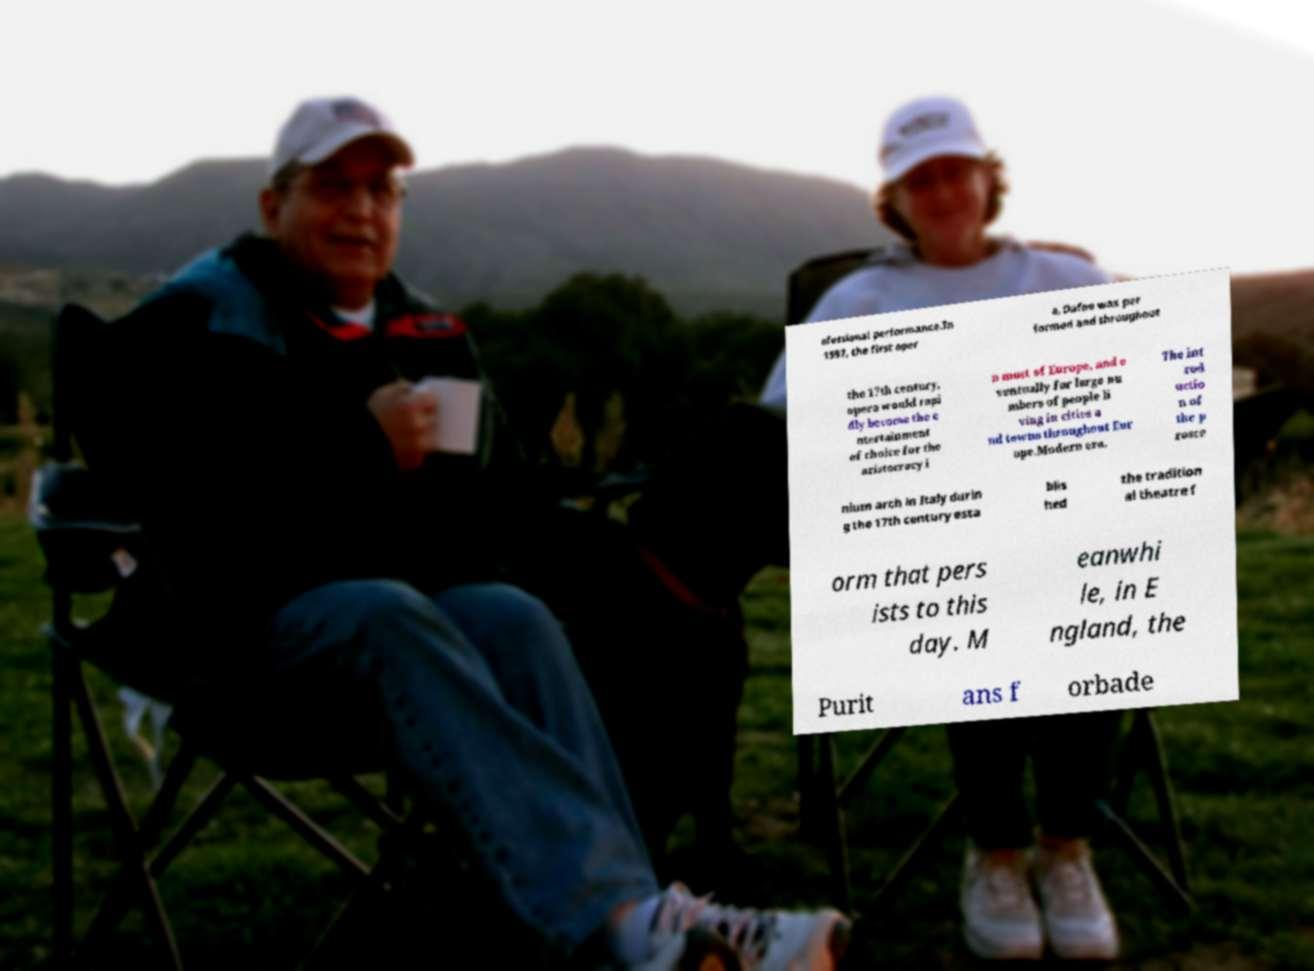Please identify and transcribe the text found in this image. ofessional performance.In 1597, the first oper a, Dafne was per formed and throughout the 17th century, opera would rapi dly become the e ntertainment of choice for the aristocracy i n most of Europe, and e ventually for large nu mbers of people li ving in cities a nd towns throughout Eur ope.Modern era. The int rod uctio n of the p rosce nium arch in Italy durin g the 17th century esta blis hed the tradition al theatre f orm that pers ists to this day. M eanwhi le, in E ngland, the Purit ans f orbade 